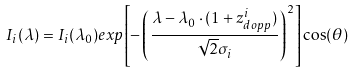Convert formula to latex. <formula><loc_0><loc_0><loc_500><loc_500>I _ { i } ( \lambda ) = I _ { i } ( \lambda _ { 0 } ) e x p { \left [ - \left ( \frac { \lambda - \lambda _ { 0 } \cdot ( 1 + z ^ { i } _ { d o p p } ) } { \sqrt { 2 } \sigma _ { i } } \right ) ^ { 2 } \right ] } \cos ( \theta )</formula> 